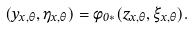Convert formula to latex. <formula><loc_0><loc_0><loc_500><loc_500>( y _ { x , \theta } , \eta _ { x , \theta } ) = \phi _ { 0 * } ( z _ { x , \theta } , \xi _ { x , \theta } ) .</formula> 